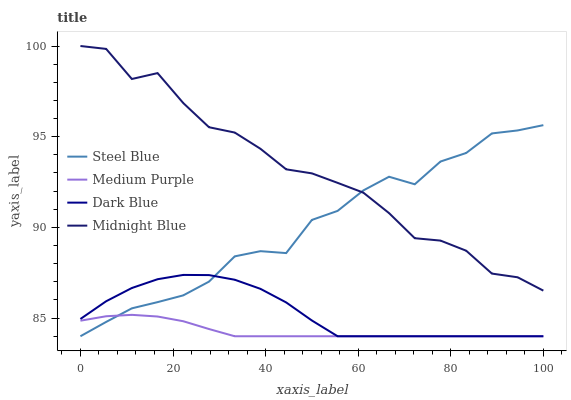Does Medium Purple have the minimum area under the curve?
Answer yes or no. Yes. Does Midnight Blue have the maximum area under the curve?
Answer yes or no. Yes. Does Dark Blue have the minimum area under the curve?
Answer yes or no. No. Does Dark Blue have the maximum area under the curve?
Answer yes or no. No. Is Medium Purple the smoothest?
Answer yes or no. Yes. Is Midnight Blue the roughest?
Answer yes or no. Yes. Is Dark Blue the smoothest?
Answer yes or no. No. Is Dark Blue the roughest?
Answer yes or no. No. Does Midnight Blue have the lowest value?
Answer yes or no. No. Does Midnight Blue have the highest value?
Answer yes or no. Yes. Does Dark Blue have the highest value?
Answer yes or no. No. Is Dark Blue less than Midnight Blue?
Answer yes or no. Yes. Is Midnight Blue greater than Medium Purple?
Answer yes or no. Yes. Does Steel Blue intersect Medium Purple?
Answer yes or no. Yes. Is Steel Blue less than Medium Purple?
Answer yes or no. No. Is Steel Blue greater than Medium Purple?
Answer yes or no. No. Does Dark Blue intersect Midnight Blue?
Answer yes or no. No. 